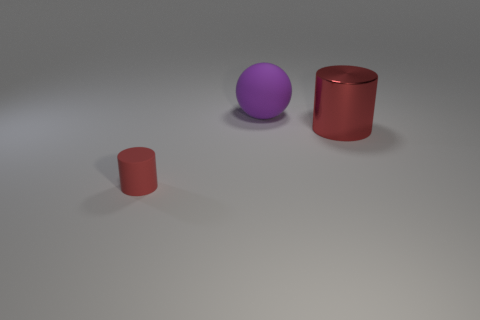Add 2 small cyan balls. How many objects exist? 5 Subtract all spheres. How many objects are left? 2 Add 3 big red things. How many big red things exist? 4 Subtract 0 yellow cylinders. How many objects are left? 3 Subtract all big shiny cylinders. Subtract all purple things. How many objects are left? 1 Add 3 big red metallic objects. How many big red metallic objects are left? 4 